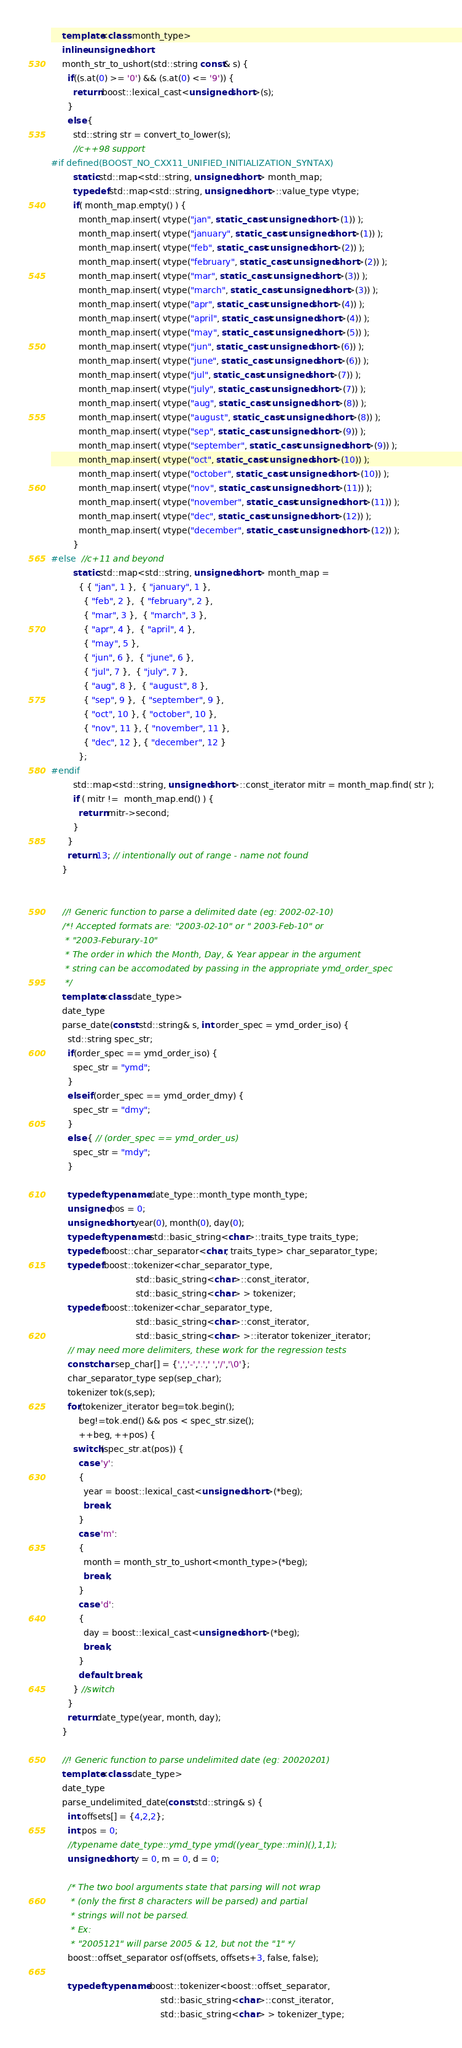Convert code to text. <code><loc_0><loc_0><loc_500><loc_500><_C++_>    template<class month_type>
    inline unsigned short
    month_str_to_ushort(std::string const& s) {
      if((s.at(0) >= '0') && (s.at(0) <= '9')) {
        return boost::lexical_cast<unsigned short>(s);
      }
      else {
        std::string str = convert_to_lower(s);
        //c++98 support
#if defined(BOOST_NO_CXX11_UNIFIED_INITIALIZATION_SYNTAX)
        static std::map<std::string, unsigned short> month_map;
        typedef std::map<std::string, unsigned short>::value_type vtype;
        if( month_map.empty() ) {
          month_map.insert( vtype("jan", static_cast<unsigned short>(1)) );
          month_map.insert( vtype("january", static_cast<unsigned short>(1)) );
          month_map.insert( vtype("feb", static_cast<unsigned short>(2)) );
          month_map.insert( vtype("february", static_cast<unsigned short>(2)) );
          month_map.insert( vtype("mar", static_cast<unsigned short>(3)) );
          month_map.insert( vtype("march", static_cast<unsigned short>(3)) );
          month_map.insert( vtype("apr", static_cast<unsigned short>(4)) );
          month_map.insert( vtype("april", static_cast<unsigned short>(4)) );
          month_map.insert( vtype("may", static_cast<unsigned short>(5)) );
          month_map.insert( vtype("jun", static_cast<unsigned short>(6)) );
          month_map.insert( vtype("june", static_cast<unsigned short>(6)) );
          month_map.insert( vtype("jul", static_cast<unsigned short>(7)) );
          month_map.insert( vtype("july", static_cast<unsigned short>(7)) );
          month_map.insert( vtype("aug", static_cast<unsigned short>(8)) );
          month_map.insert( vtype("august", static_cast<unsigned short>(8)) );
          month_map.insert( vtype("sep", static_cast<unsigned short>(9)) );
          month_map.insert( vtype("september", static_cast<unsigned short>(9)) );
          month_map.insert( vtype("oct", static_cast<unsigned short>(10)) );
          month_map.insert( vtype("october", static_cast<unsigned short>(10)) );
          month_map.insert( vtype("nov", static_cast<unsigned short>(11)) );
          month_map.insert( vtype("november", static_cast<unsigned short>(11)) );
          month_map.insert( vtype("dec", static_cast<unsigned short>(12)) );
          month_map.insert( vtype("december", static_cast<unsigned short>(12)) );
        }
#else  //c+11 and beyond
        static std::map<std::string, unsigned short> month_map =
          { { "jan", 1 },  { "january", 1 },
            { "feb", 2 },  { "february", 2 },
            { "mar", 3 },  { "march", 3 },
            { "apr", 4 },  { "april", 4 },
            { "may", 5 },
            { "jun", 6 },  { "june", 6 },
            { "jul", 7 },  { "july", 7 },
            { "aug", 8 },  { "august", 8 },
            { "sep", 9 },  { "september", 9 },
            { "oct", 10 }, { "october", 10 },
            { "nov", 11 }, { "november", 11 },
            { "dec", 12 }, { "december", 12 }
          };
#endif
        std::map<std::string, unsigned short>::const_iterator mitr = month_map.find( str );
        if ( mitr !=  month_map.end() ) {
          return mitr->second;
        }
      }
      return 13; // intentionally out of range - name not found
    }
 

    //! Generic function to parse a delimited date (eg: 2002-02-10)
    /*! Accepted formats are: "2003-02-10" or " 2003-Feb-10" or
     * "2003-Feburary-10"
     * The order in which the Month, Day, & Year appear in the argument
     * string can be accomodated by passing in the appropriate ymd_order_spec
     */
    template<class date_type>
    date_type
    parse_date(const std::string& s, int order_spec = ymd_order_iso) {
      std::string spec_str;
      if(order_spec == ymd_order_iso) {
        spec_str = "ymd";
      }
      else if(order_spec == ymd_order_dmy) {
        spec_str = "dmy";
      }
      else { // (order_spec == ymd_order_us)
        spec_str = "mdy";
      }

      typedef typename date_type::month_type month_type;
      unsigned pos = 0;
      unsigned short year(0), month(0), day(0);
      typedef typename std::basic_string<char>::traits_type traits_type;
      typedef boost::char_separator<char, traits_type> char_separator_type;
      typedef boost::tokenizer<char_separator_type,
                               std::basic_string<char>::const_iterator,
                               std::basic_string<char> > tokenizer;
      typedef boost::tokenizer<char_separator_type,
                               std::basic_string<char>::const_iterator,
                               std::basic_string<char> >::iterator tokenizer_iterator;
      // may need more delimiters, these work for the regression tests
      const char sep_char[] = {',','-','.',' ','/','\0'};
      char_separator_type sep(sep_char);
      tokenizer tok(s,sep);
      for(tokenizer_iterator beg=tok.begin();
          beg!=tok.end() && pos < spec_str.size();
          ++beg, ++pos) {
        switch(spec_str.at(pos)) {
          case 'y':
          {
            year = boost::lexical_cast<unsigned short>(*beg);
            break;
          }
          case 'm':
          {
            month = month_str_to_ushort<month_type>(*beg);
            break;
          }
          case 'd':
          {
            day = boost::lexical_cast<unsigned short>(*beg);
            break;
          }
          default: break;
        } //switch
      }
      return date_type(year, month, day);
    }

    //! Generic function to parse undelimited date (eg: 20020201)
    template<class date_type>
    date_type
    parse_undelimited_date(const std::string& s) {
      int offsets[] = {4,2,2};
      int pos = 0;
      //typename date_type::ymd_type ymd((year_type::min)(),1,1);
      unsigned short y = 0, m = 0, d = 0;

      /* The two bool arguments state that parsing will not wrap
       * (only the first 8 characters will be parsed) and partial
       * strings will not be parsed.
       * Ex:
       * "2005121" will parse 2005 & 12, but not the "1" */
      boost::offset_separator osf(offsets, offsets+3, false, false);

      typedef typename boost::tokenizer<boost::offset_separator,
                                        std::basic_string<char>::const_iterator,
                                        std::basic_string<char> > tokenizer_type;</code> 